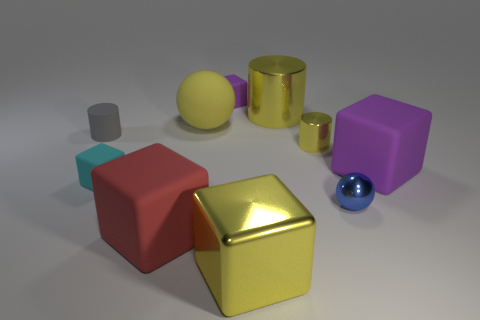The rubber ball that is the same color as the large shiny block is what size?
Make the answer very short. Large. What shape is the large rubber object that is the same color as the big cylinder?
Your response must be concise. Sphere. Is there anything else that has the same color as the big metallic cylinder?
Your answer should be very brief. Yes. There is a big rubber sphere; is it the same color as the big object that is in front of the red object?
Give a very brief answer. Yes. Does the rubber ball have the same color as the large cylinder?
Your answer should be compact. Yes. How many cubes are the same color as the large sphere?
Ensure brevity in your answer.  1. What material is the purple object behind the yellow matte object?
Your answer should be very brief. Rubber. How many matte things are tiny balls or big red balls?
Keep it short and to the point. 0. There is a big ball that is the same material as the tiny gray cylinder; what is its color?
Offer a very short reply. Yellow. There is a large yellow object in front of the big object that is on the left side of the large rubber ball; what is it made of?
Provide a succinct answer. Metal. 